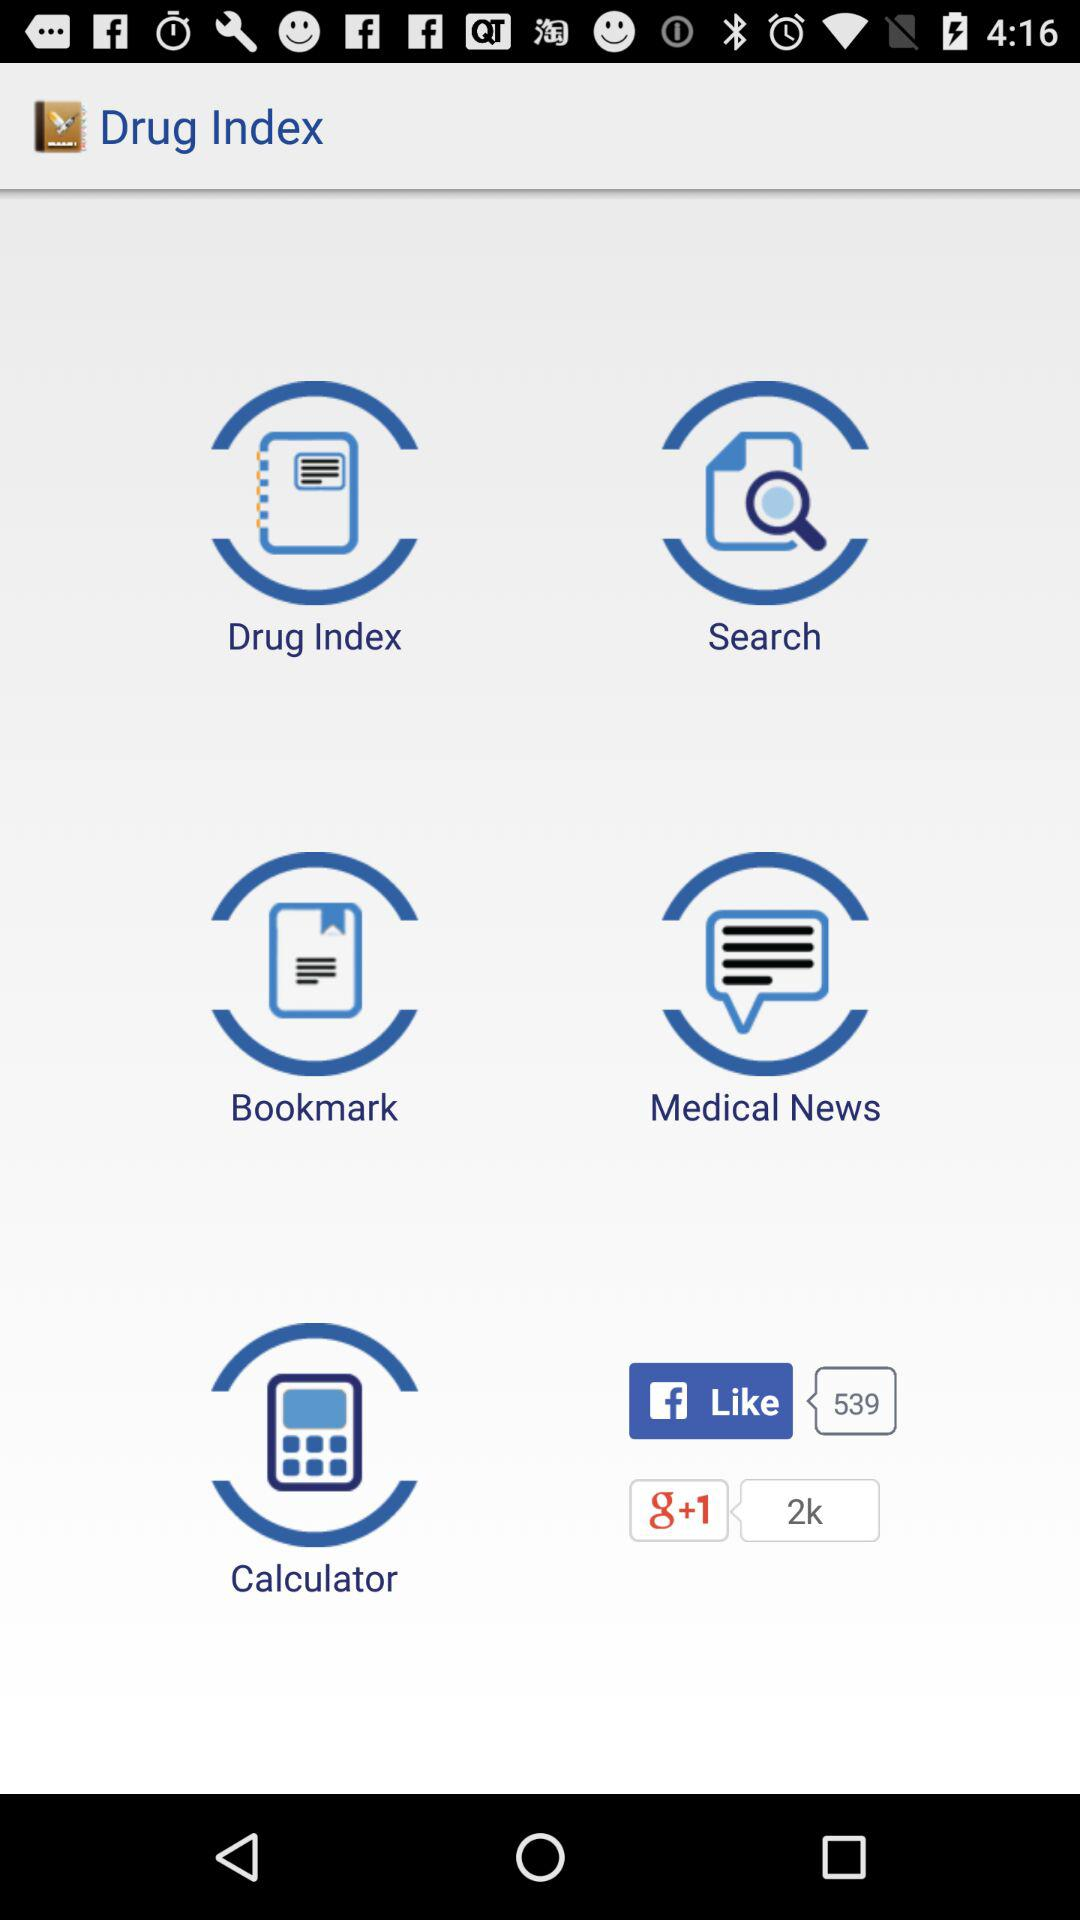What is the application name? The application name is "Drug Index". 